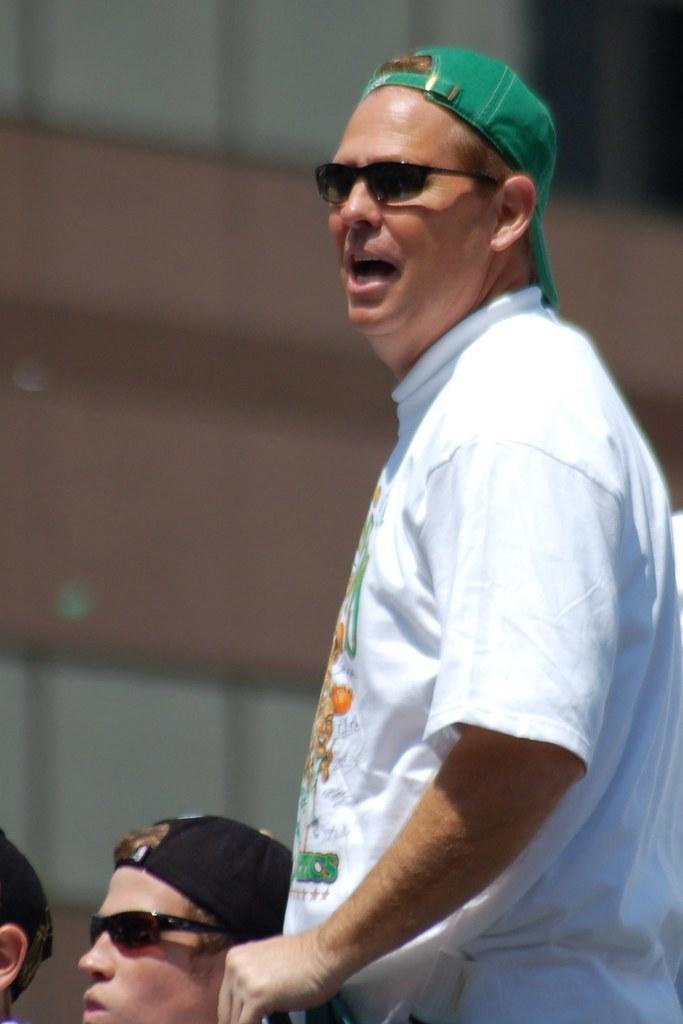How would you summarize this image in a sentence or two? In this image I can see some people. In the background, I can see the wall. 